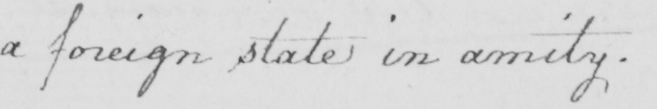Please transcribe the handwritten text in this image. a foreign state in amity . 